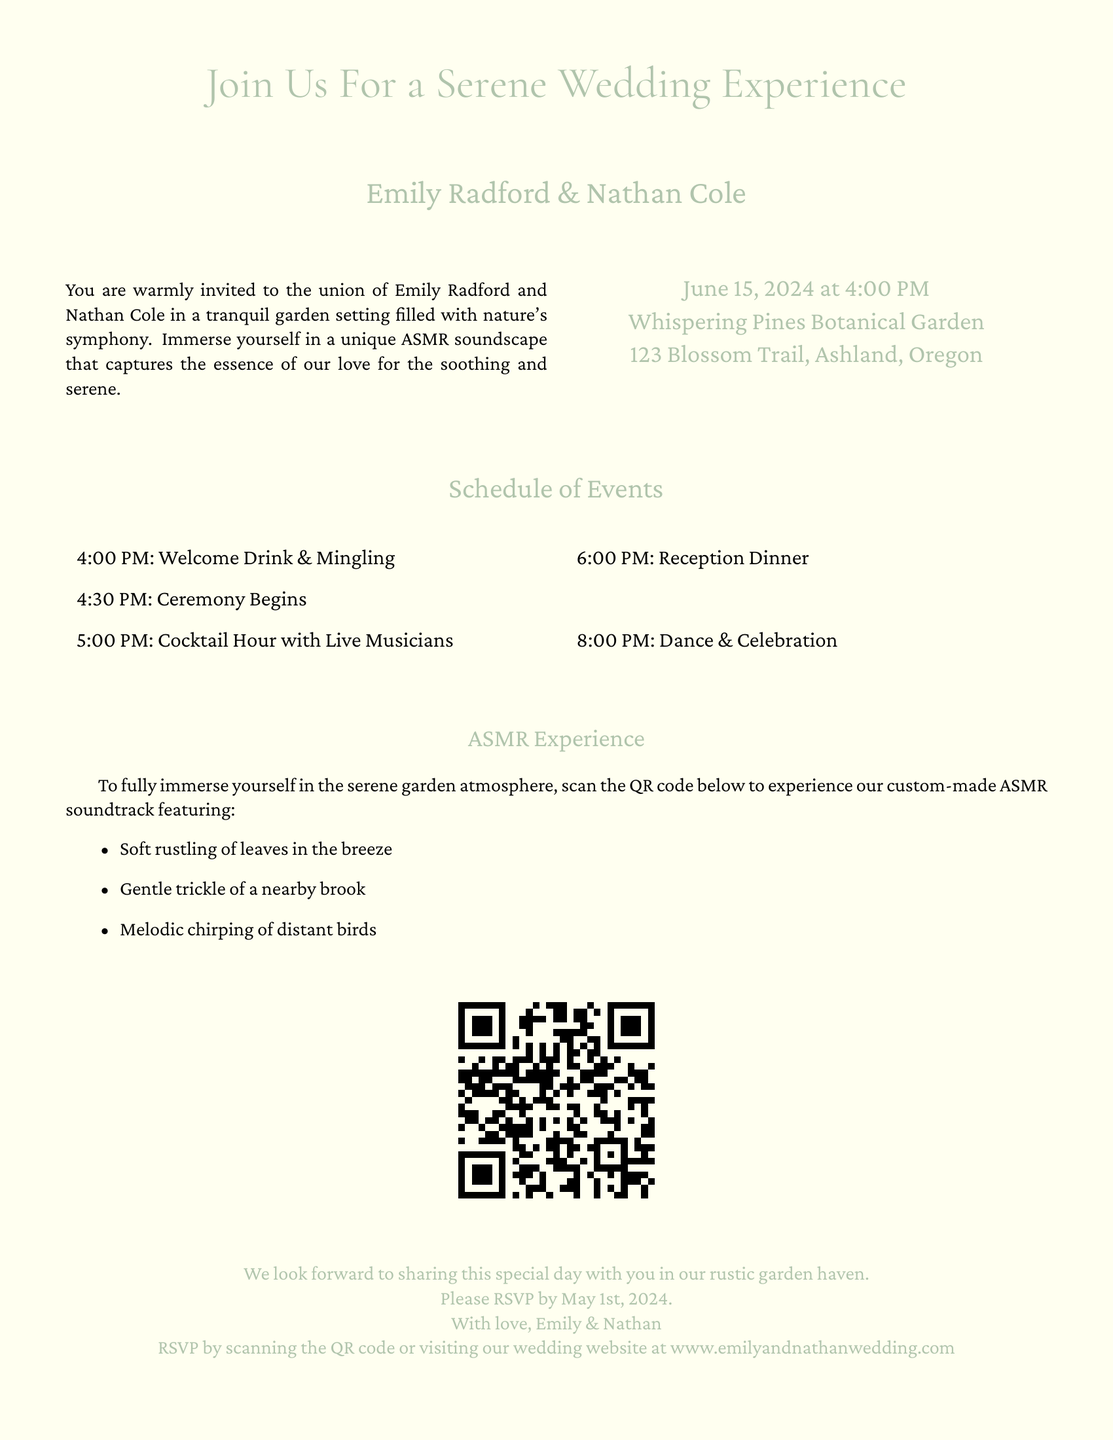What are the names of the couple? The document lists the names of the couple, Emily Radford and Nathan Cole.
Answer: Emily Radford & Nathan Cole When is the wedding date? The wedding date is clearly mentioned in the invitation details.
Answer: June 15, 2024 What time does the ceremony begin? The schedule of events shows the start time of the ceremony.
Answer: 4:30 PM Where is the wedding venue located? The invitation provides the address of the wedding venue.
Answer: Whispering Pines Botanical Garden, 123 Blossom Trail, Ashland, Oregon What type of soundscape is included in the invitation? The invitation describes the nature-inspired feature embedded within it.
Answer: ASMR soundscape What are some of the sounds featured in the ASMR experience? The document lists specific sounds that the ASMR soundtrack includes.
Answer: Soft rustling of leaves, gentle trickle of a nearby brook, melodic chirping of distant birds When is the RSVP deadline? The invitation specifies the date by which guests should respond.
Answer: May 1st, 2024 What is the first event listed in the schedule? The schedule of events outlines the order of occurrences starting with the first.
Answer: Welcome Drink & Mingling What can guests do to experience the ASMR soundtrack? The invitation mentions how guests can immerse themselves in the ASMR experience.
Answer: Scan the QR code What sentiment do the couple express in the closing? The closing of the invitation conveys the couple's feelings about the wedding day.
Answer: With love, Emily & Nathan 